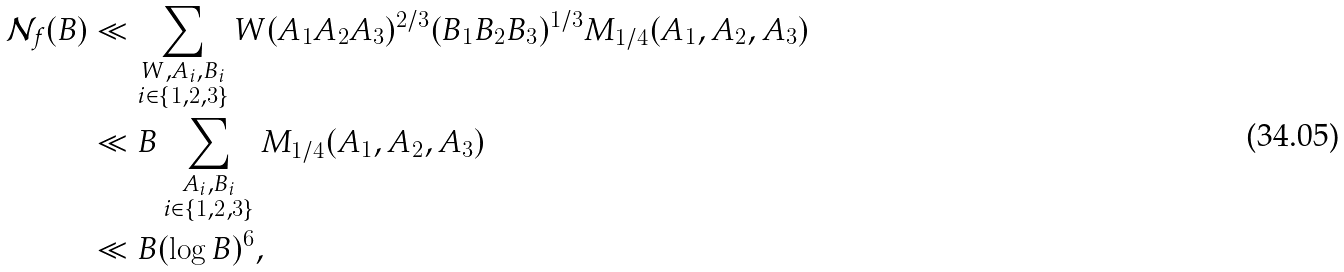<formula> <loc_0><loc_0><loc_500><loc_500>\mathcal { N } _ { f } ( B ) & \ll \sum _ { \substack { W , A _ { i } , B _ { i } \\ i \in \{ 1 , 2 , 3 \} } } W ( A _ { 1 } A _ { 2 } A _ { 3 } ) ^ { 2 / 3 } ( B _ { 1 } B _ { 2 } B _ { 3 } ) ^ { 1 / 3 } M _ { 1 / 4 } ( A _ { 1 } , A _ { 2 } , A _ { 3 } ) \\ & \ll B \sum _ { \substack { A _ { i } , B _ { i } \\ i \in \{ 1 , 2 , 3 \} } } M _ { 1 / 4 } ( A _ { 1 } , A _ { 2 } , A _ { 3 } ) \\ & \ll B ( \log B ) ^ { 6 } ,</formula> 